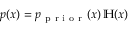Convert formula to latex. <formula><loc_0><loc_0><loc_500><loc_500>p ( x ) = p _ { p r i o r } ( x ) \, \mathbb { H } ( x )</formula> 